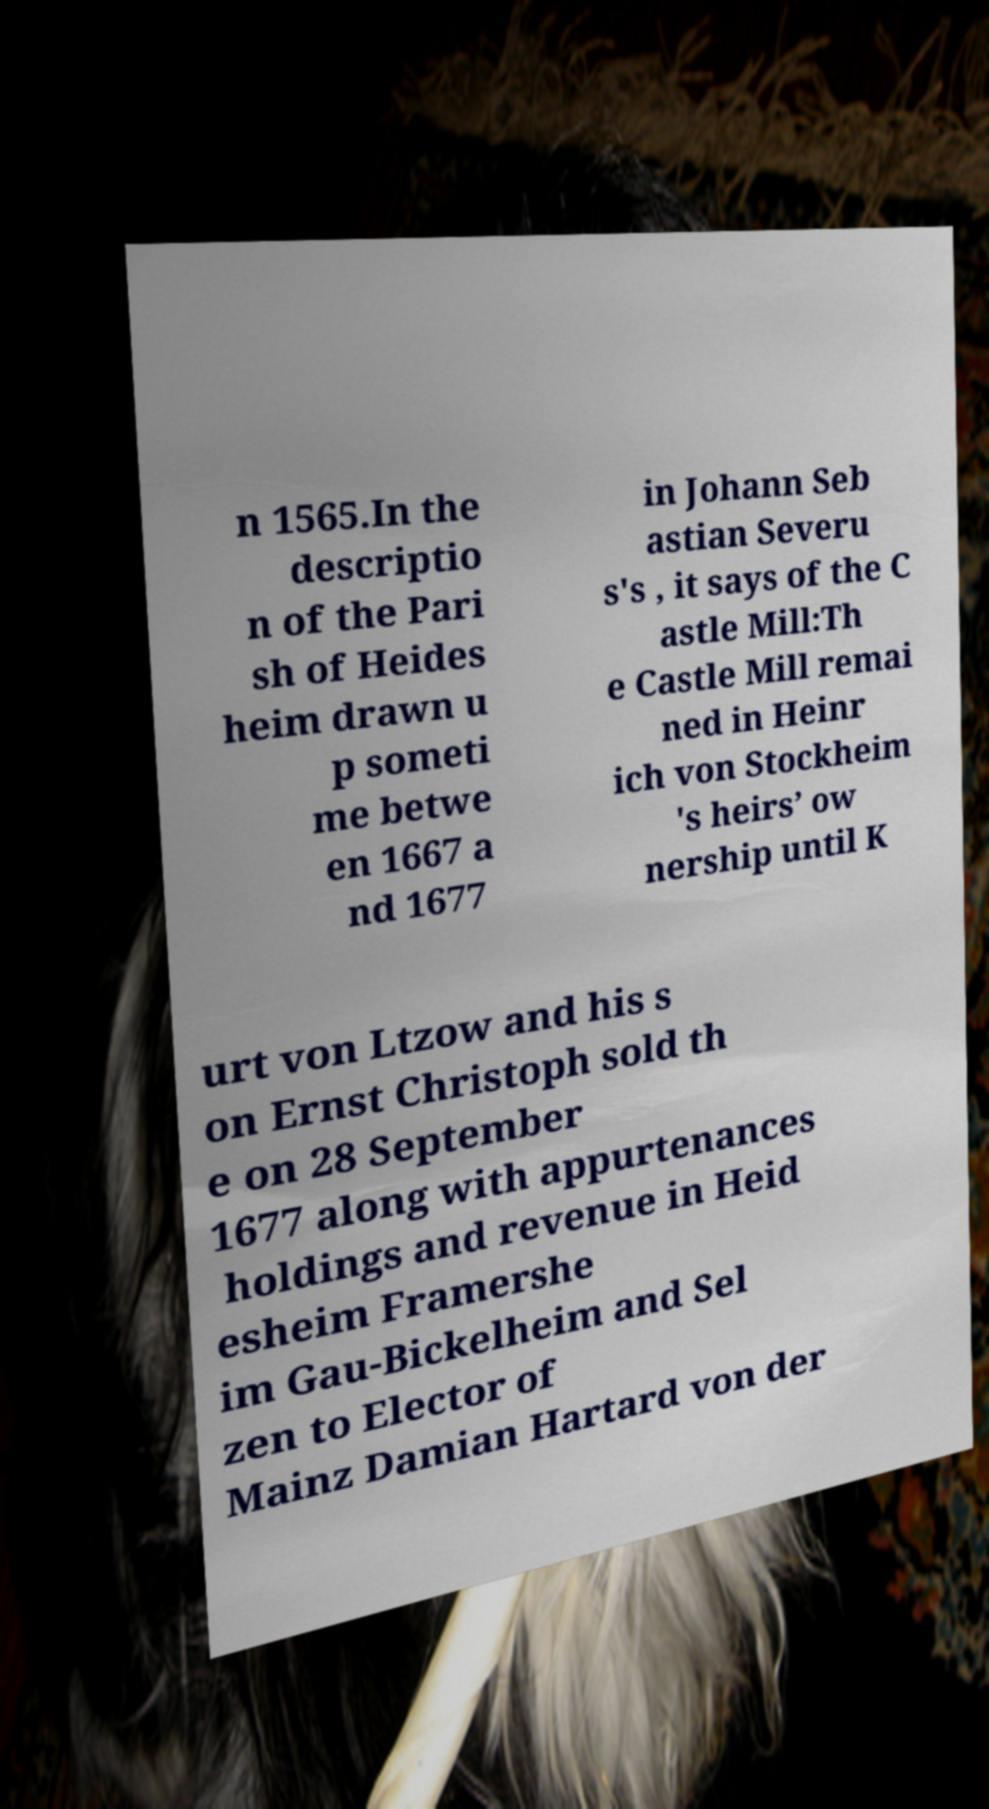Could you extract and type out the text from this image? n 1565.In the descriptio n of the Pari sh of Heides heim drawn u p someti me betwe en 1667 a nd 1677 in Johann Seb astian Severu s's , it says of the C astle Mill:Th e Castle Mill remai ned in Heinr ich von Stockheim 's heirs’ ow nership until K urt von Ltzow and his s on Ernst Christoph sold th e on 28 September 1677 along with appurtenances holdings and revenue in Heid esheim Framershe im Gau-Bickelheim and Sel zen to Elector of Mainz Damian Hartard von der 